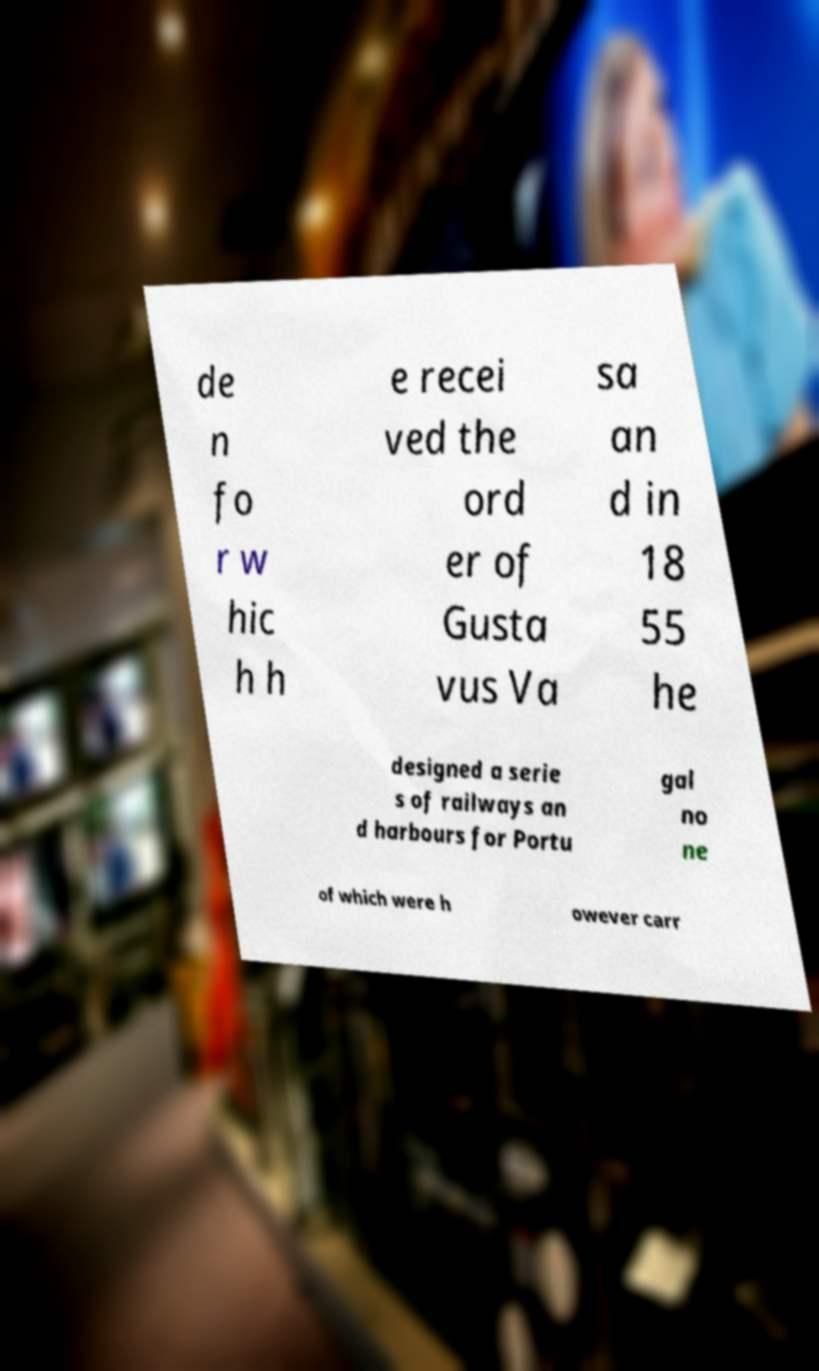Can you accurately transcribe the text from the provided image for me? de n fo r w hic h h e recei ved the ord er of Gusta vus Va sa an d in 18 55 he designed a serie s of railways an d harbours for Portu gal no ne of which were h owever carr 